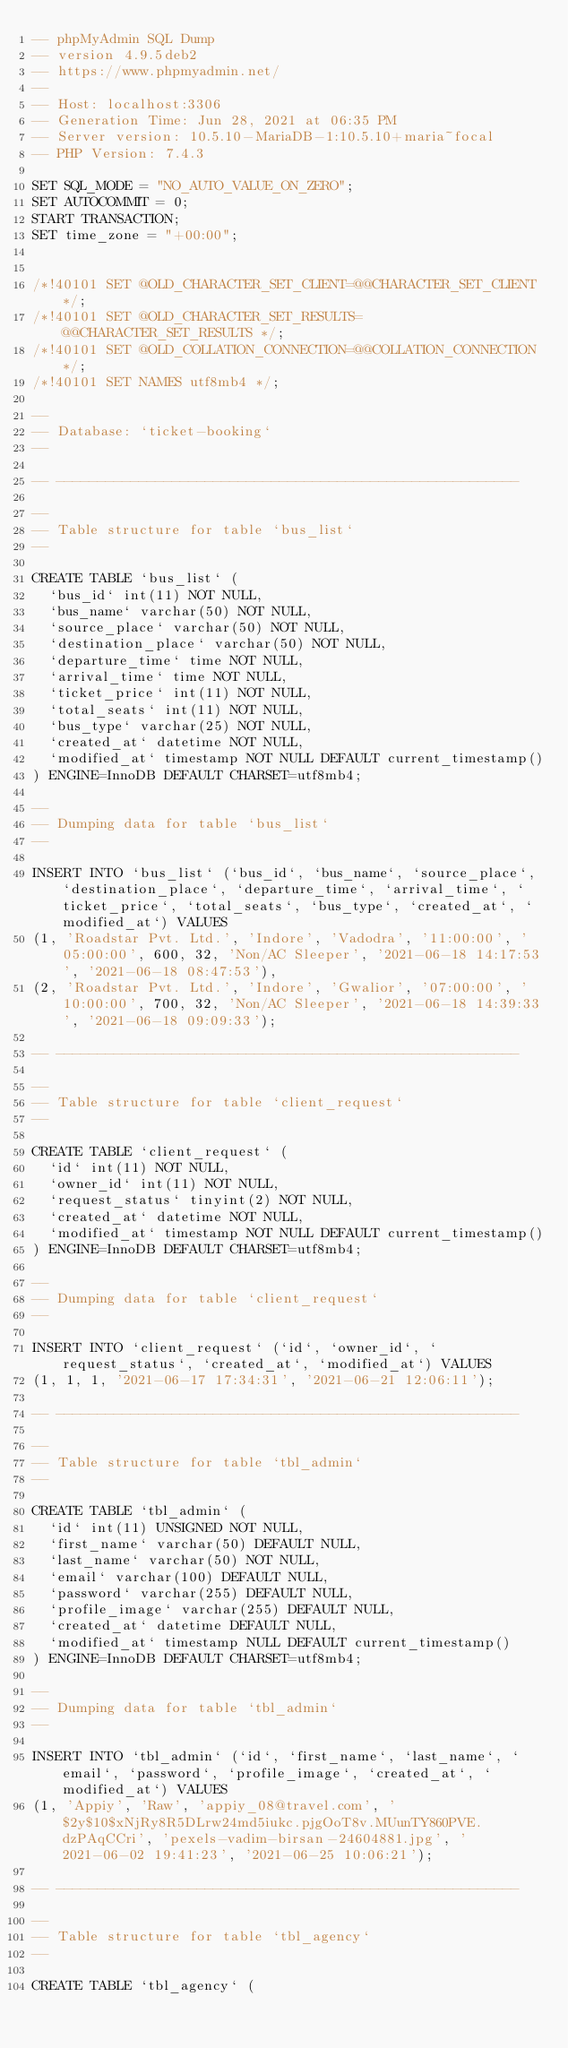<code> <loc_0><loc_0><loc_500><loc_500><_SQL_>-- phpMyAdmin SQL Dump
-- version 4.9.5deb2
-- https://www.phpmyadmin.net/
--
-- Host: localhost:3306
-- Generation Time: Jun 28, 2021 at 06:35 PM
-- Server version: 10.5.10-MariaDB-1:10.5.10+maria~focal
-- PHP Version: 7.4.3

SET SQL_MODE = "NO_AUTO_VALUE_ON_ZERO";
SET AUTOCOMMIT = 0;
START TRANSACTION;
SET time_zone = "+00:00";


/*!40101 SET @OLD_CHARACTER_SET_CLIENT=@@CHARACTER_SET_CLIENT */;
/*!40101 SET @OLD_CHARACTER_SET_RESULTS=@@CHARACTER_SET_RESULTS */;
/*!40101 SET @OLD_COLLATION_CONNECTION=@@COLLATION_CONNECTION */;
/*!40101 SET NAMES utf8mb4 */;

--
-- Database: `ticket-booking`
--

-- --------------------------------------------------------

--
-- Table structure for table `bus_list`
--

CREATE TABLE `bus_list` (
  `bus_id` int(11) NOT NULL,
  `bus_name` varchar(50) NOT NULL,
  `source_place` varchar(50) NOT NULL,
  `destination_place` varchar(50) NOT NULL,
  `departure_time` time NOT NULL,
  `arrival_time` time NOT NULL,
  `ticket_price` int(11) NOT NULL,
  `total_seats` int(11) NOT NULL,
  `bus_type` varchar(25) NOT NULL,
  `created_at` datetime NOT NULL,
  `modified_at` timestamp NOT NULL DEFAULT current_timestamp()
) ENGINE=InnoDB DEFAULT CHARSET=utf8mb4;

--
-- Dumping data for table `bus_list`
--

INSERT INTO `bus_list` (`bus_id`, `bus_name`, `source_place`, `destination_place`, `departure_time`, `arrival_time`, `ticket_price`, `total_seats`, `bus_type`, `created_at`, `modified_at`) VALUES
(1, 'Roadstar Pvt. Ltd.', 'Indore', 'Vadodra', '11:00:00', '05:00:00', 600, 32, 'Non/AC Sleeper', '2021-06-18 14:17:53', '2021-06-18 08:47:53'),
(2, 'Roadstar Pvt. Ltd.', 'Indore', 'Gwalior', '07:00:00', '10:00:00', 700, 32, 'Non/AC Sleeper', '2021-06-18 14:39:33', '2021-06-18 09:09:33');

-- --------------------------------------------------------

--
-- Table structure for table `client_request`
--

CREATE TABLE `client_request` (
  `id` int(11) NOT NULL,
  `owner_id` int(11) NOT NULL,
  `request_status` tinyint(2) NOT NULL,
  `created_at` datetime NOT NULL,
  `modified_at` timestamp NOT NULL DEFAULT current_timestamp()
) ENGINE=InnoDB DEFAULT CHARSET=utf8mb4;

--
-- Dumping data for table `client_request`
--

INSERT INTO `client_request` (`id`, `owner_id`, `request_status`, `created_at`, `modified_at`) VALUES
(1, 1, 1, '2021-06-17 17:34:31', '2021-06-21 12:06:11');

-- --------------------------------------------------------

--
-- Table structure for table `tbl_admin`
--

CREATE TABLE `tbl_admin` (
  `id` int(11) UNSIGNED NOT NULL,
  `first_name` varchar(50) DEFAULT NULL,
  `last_name` varchar(50) NOT NULL,
  `email` varchar(100) DEFAULT NULL,
  `password` varchar(255) DEFAULT NULL,
  `profile_image` varchar(255) DEFAULT NULL,
  `created_at` datetime DEFAULT NULL,
  `modified_at` timestamp NULL DEFAULT current_timestamp()
) ENGINE=InnoDB DEFAULT CHARSET=utf8mb4;

--
-- Dumping data for table `tbl_admin`
--

INSERT INTO `tbl_admin` (`id`, `first_name`, `last_name`, `email`, `password`, `profile_image`, `created_at`, `modified_at`) VALUES
(1, 'Appiy', 'Raw', 'appiy_08@travel.com', '$2y$10$xNjRy8R5DLrw24md5iukc.pjgOoT8v.MUunTY860PVE.dzPAqCCri', 'pexels-vadim-birsan-24604881.jpg', '2021-06-02 19:41:23', '2021-06-25 10:06:21');

-- --------------------------------------------------------

--
-- Table structure for table `tbl_agency`
--

CREATE TABLE `tbl_agency` (</code> 